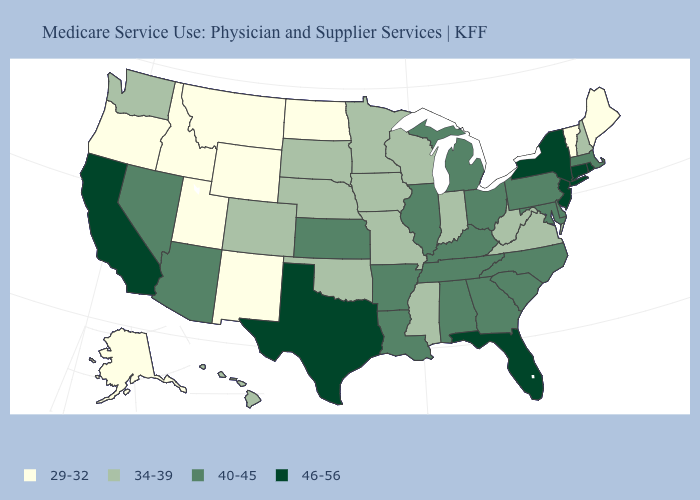What is the value of Massachusetts?
Short answer required. 40-45. Does New Mexico have the lowest value in the USA?
Answer briefly. Yes. Among the states that border Maine , which have the lowest value?
Be succinct. New Hampshire. What is the value of Massachusetts?
Answer briefly. 40-45. Does Georgia have a lower value than Rhode Island?
Quick response, please. Yes. What is the value of Kansas?
Give a very brief answer. 40-45. What is the value of Montana?
Short answer required. 29-32. What is the value of Wyoming?
Be succinct. 29-32. What is the value of North Carolina?
Concise answer only. 40-45. Name the states that have a value in the range 34-39?
Concise answer only. Colorado, Hawaii, Indiana, Iowa, Minnesota, Mississippi, Missouri, Nebraska, New Hampshire, Oklahoma, South Dakota, Virginia, Washington, West Virginia, Wisconsin. How many symbols are there in the legend?
Be succinct. 4. Among the states that border Oregon , does Nevada have the highest value?
Short answer required. No. Does Washington have the same value as Illinois?
Give a very brief answer. No. Among the states that border Virginia , does Maryland have the lowest value?
Give a very brief answer. No. Is the legend a continuous bar?
Write a very short answer. No. 